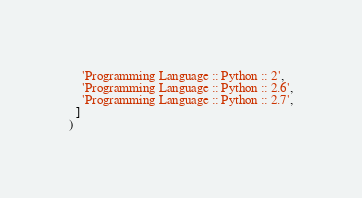Convert code to text. <code><loc_0><loc_0><loc_500><loc_500><_Python_>    'Programming Language :: Python :: 2',
    'Programming Language :: Python :: 2.6',
    'Programming Language :: Python :: 2.7',
  ]
)
</code> 